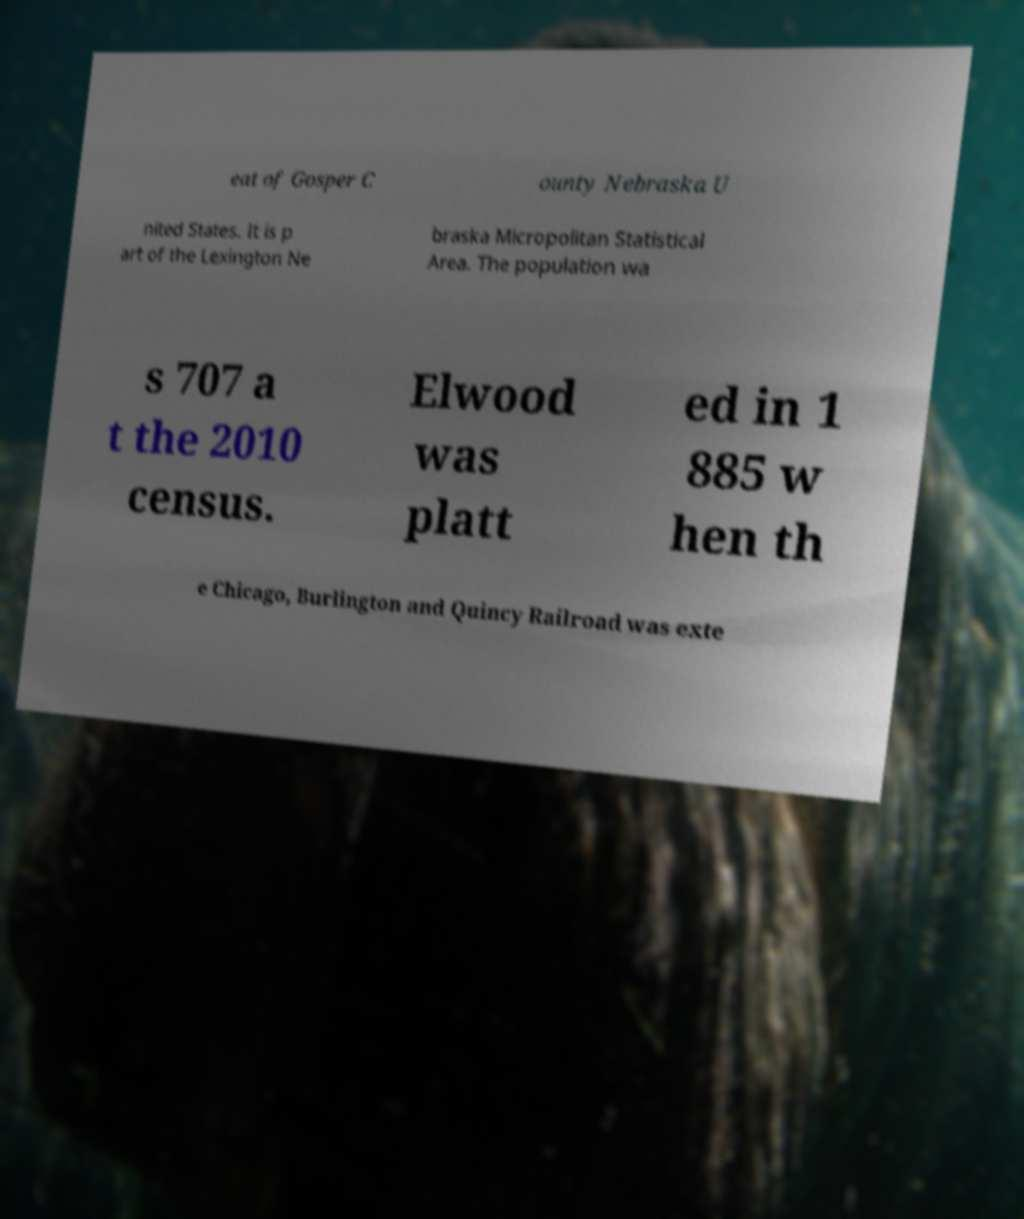Can you accurately transcribe the text from the provided image for me? eat of Gosper C ounty Nebraska U nited States. It is p art of the Lexington Ne braska Micropolitan Statistical Area. The population wa s 707 a t the 2010 census. Elwood was platt ed in 1 885 w hen th e Chicago, Burlington and Quincy Railroad was exte 